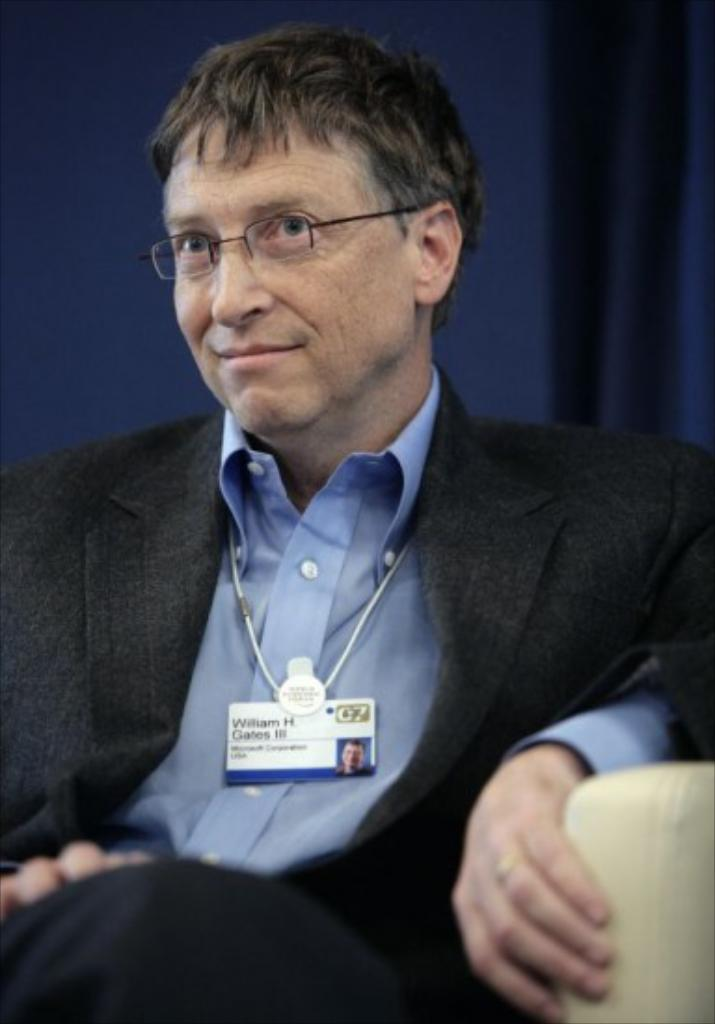What is the person in the image doing? There is a person sitting on a chair in the image. What can be seen in the background of the image? There are curtains in the background of the image. How much wealth does the person in the image possess? There is no information about the person's wealth in the image. Is there any smoke visible in the image? There is no smoke present in the image. 